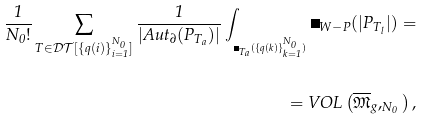<formula> <loc_0><loc_0><loc_500><loc_500>\frac { 1 } { N _ { 0 } ! } \sum _ { T \in \mathcal { D T } [ \{ q ( i ) \} _ { i = 1 } ^ { N _ { 0 } } ] } \frac { 1 } { | A u t _ { \partial } ( P _ { T _ { a } } ) | } \int _ { _ { \Omega _ { T _ { a } } ( \{ q ( k ) \} _ { k = 1 } ^ { N _ { 0 } } ) } } \Omega _ { W - P } ( | P _ { T _ { l } } | ) = \\ \\ = V O L \left ( \overline { \mathfrak { M } } _ { g } , _ { N _ { 0 } } \right ) ,</formula> 